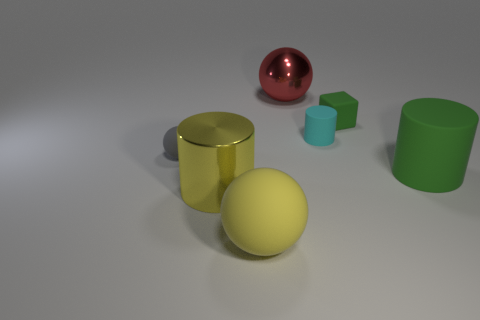Subtract all red spheres. How many spheres are left? 2 Add 3 large gray matte spheres. How many objects exist? 10 Subtract all cyan cylinders. How many cylinders are left? 2 Subtract all cubes. How many objects are left? 6 Subtract 1 spheres. How many spheres are left? 2 Subtract all large brown shiny balls. Subtract all large yellow metallic cylinders. How many objects are left? 6 Add 6 yellow spheres. How many yellow spheres are left? 7 Add 1 tiny red cylinders. How many tiny red cylinders exist? 1 Subtract 0 brown cylinders. How many objects are left? 7 Subtract all yellow blocks. Subtract all blue cylinders. How many blocks are left? 1 